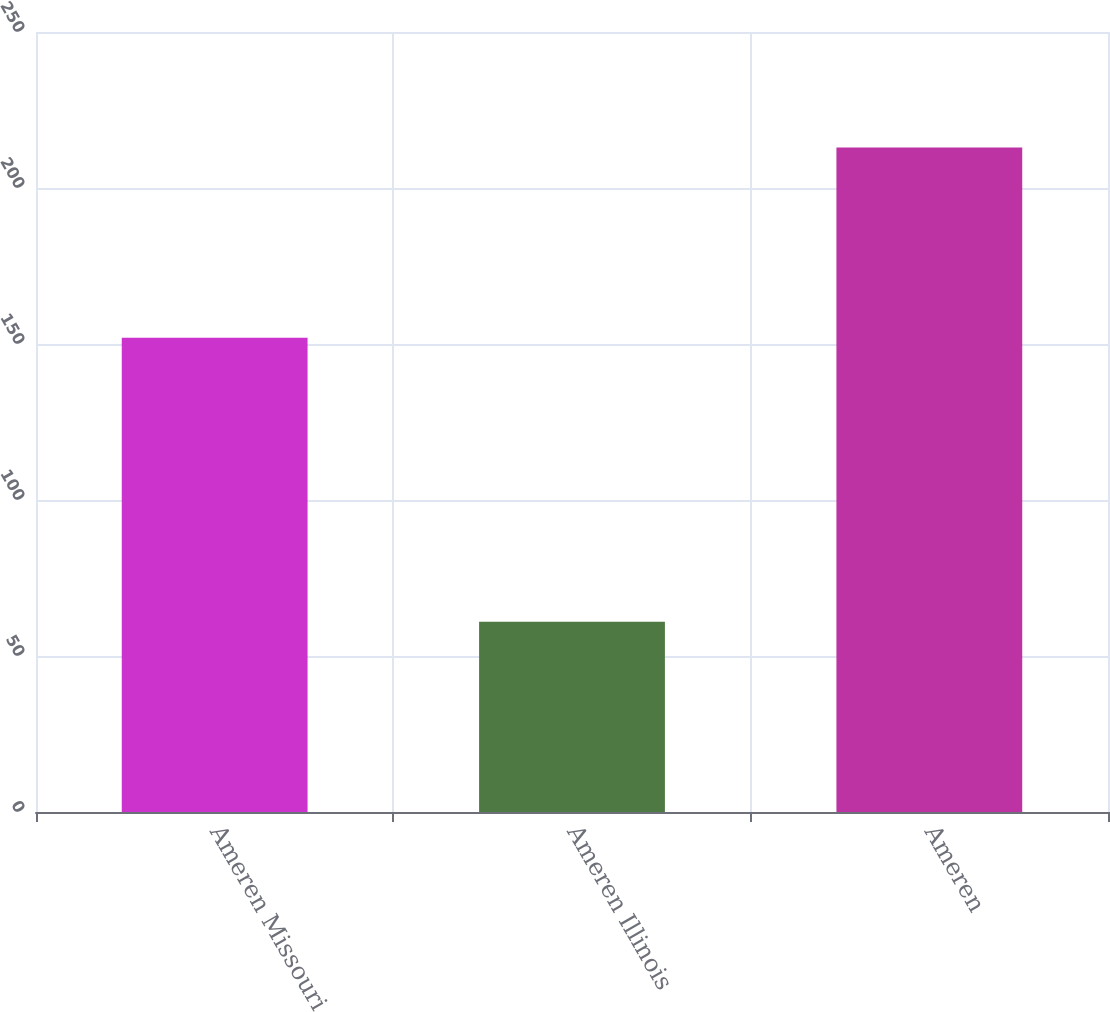Convert chart. <chart><loc_0><loc_0><loc_500><loc_500><bar_chart><fcel>Ameren Missouri<fcel>Ameren Illinois<fcel>Ameren<nl><fcel>152<fcel>61<fcel>213<nl></chart> 